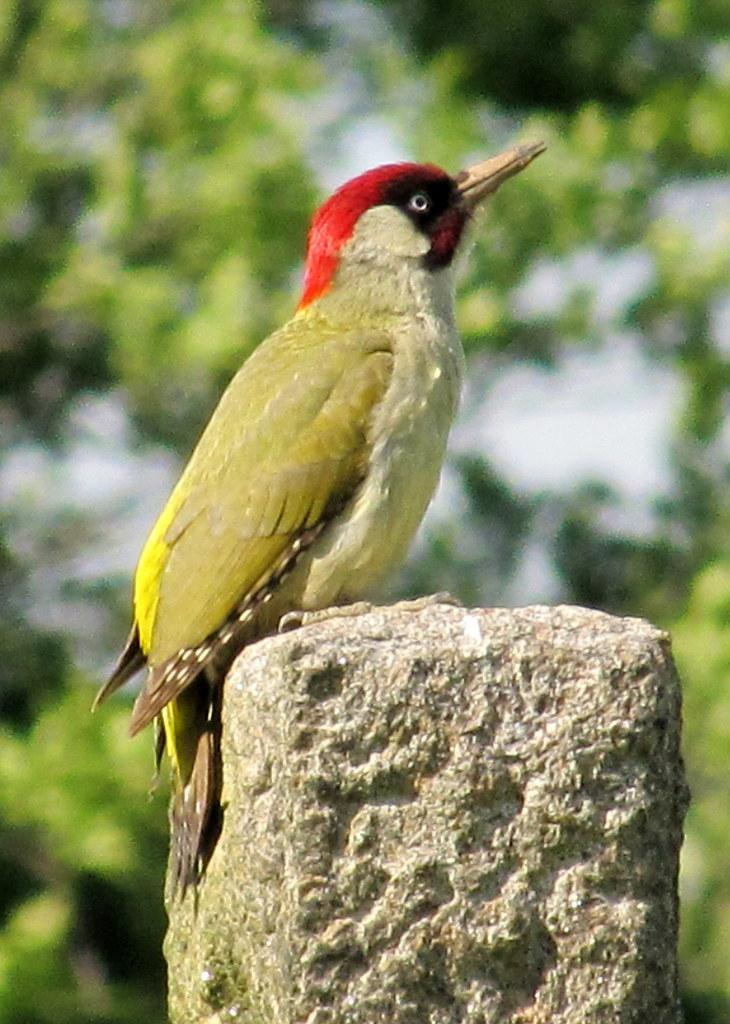What type of animal can be seen in the image? There is a bird in the image. Where is the bird located? The bird is on a stone. What can be observed in the background of the image? The background is green and blurred. How many copies of the worm can be seen in the image? There is no worm present in the image. What type of planes are flying in the background of the image? There are no planes visible in the image; the background is green and blurred. 